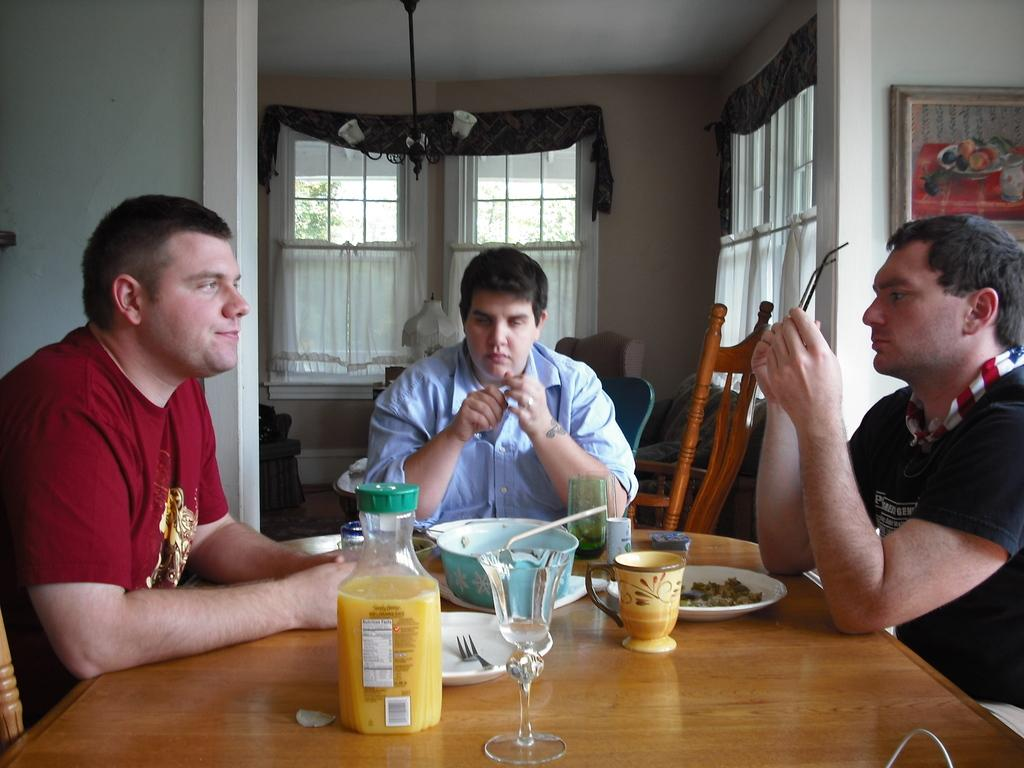How many people are sitting at the table in the image? There are three men sitting at a table in the image. What can be found on the table besides the men? There are eatables in plates, a container with juice, and glasses on the table. What can be seen in the background of the image? There is some furniture and windows in the background. What type of ship can be seen sailing in the background of the image? There is no ship visible in the image; it only shows three men sitting at a table with eatables, a juice container, and glasses, along with furniture and windows in the background. 